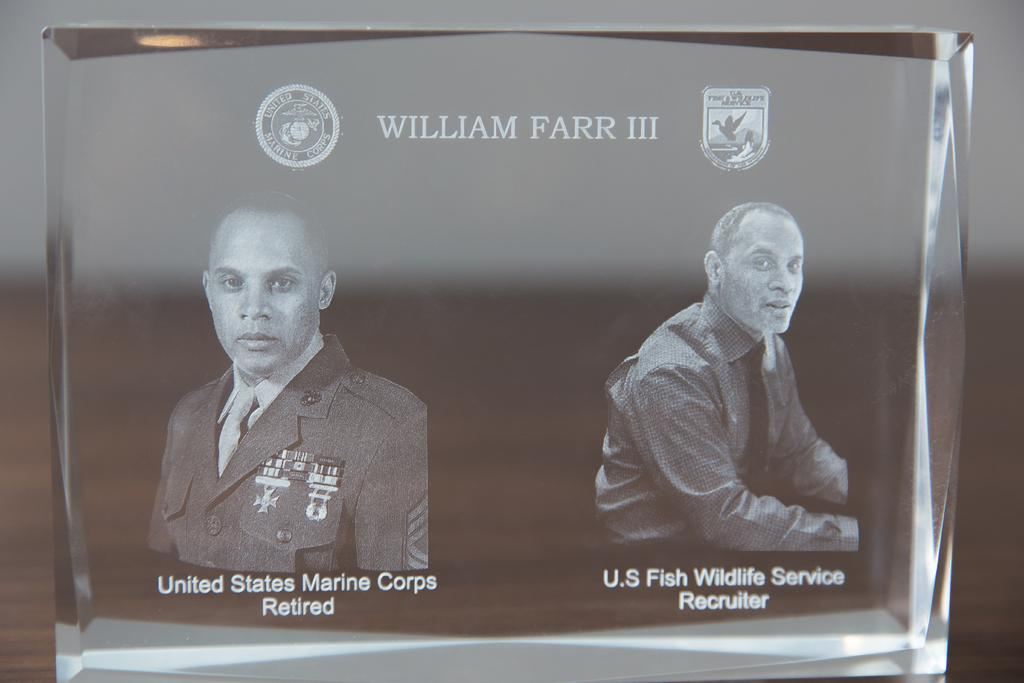What is the main subject of the image? The main subject of the image is a black object. What is depicted on the black object? The black object has two pictures of men on it. Where is text located in the image? There is text written at the bottom and top of the image. How many logos are present in the image? There are two logos present in the image. Can you tell me where the giraffe is located in the image? There is no giraffe present in the image. What type of paper is used for the text in the image? The image does not specify the type of paper used for the text, as it is a digital image. 